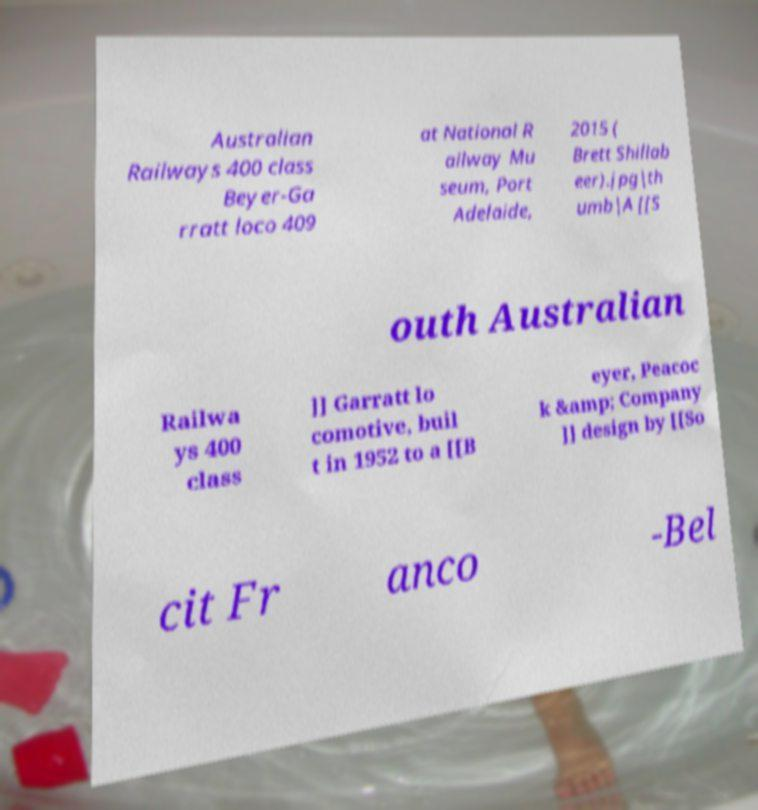There's text embedded in this image that I need extracted. Can you transcribe it verbatim? Australian Railways 400 class Beyer-Ga rratt loco 409 at National R ailway Mu seum, Port Adelaide, 2015 ( Brett Shillab eer).jpg|th umb|A [[S outh Australian Railwa ys 400 class ]] Garratt lo comotive, buil t in 1952 to a [[B eyer, Peacoc k &amp; Company ]] design by [[So cit Fr anco -Bel 